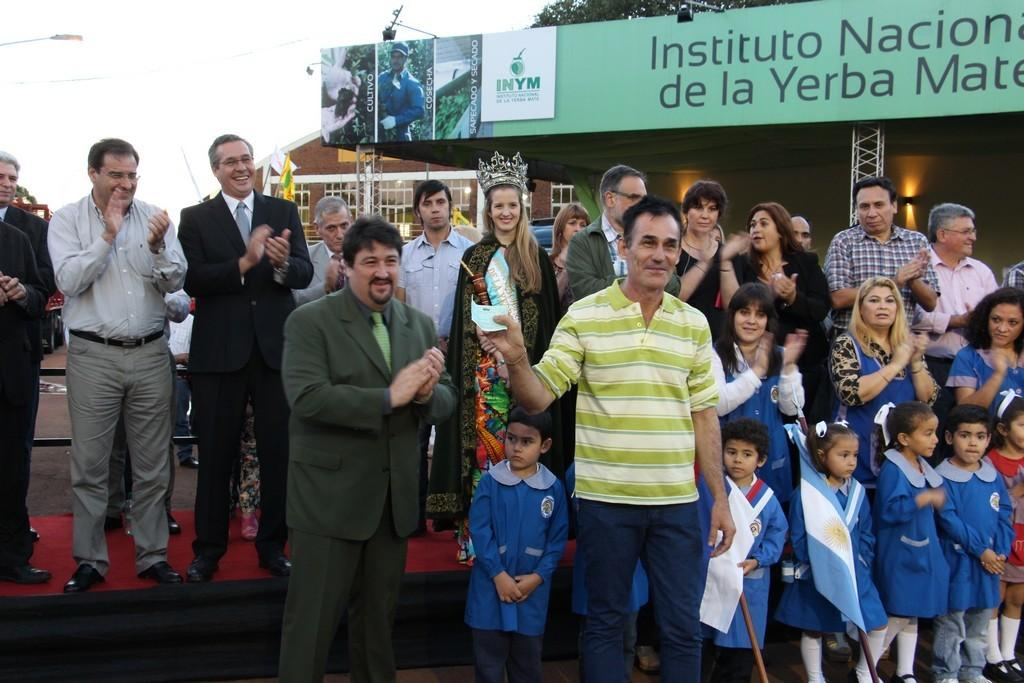What are the people in the image doing? Some people are clapping their hands in the image. What can be seen in the background of the image? There are buildings, trees, and the sky visible in the background of the image. Can you see any goldfish swimming in the image? There are no goldfish present in the image. What type of pickle is being used as a prop by the people in the image? There is no pickle present in the image. 